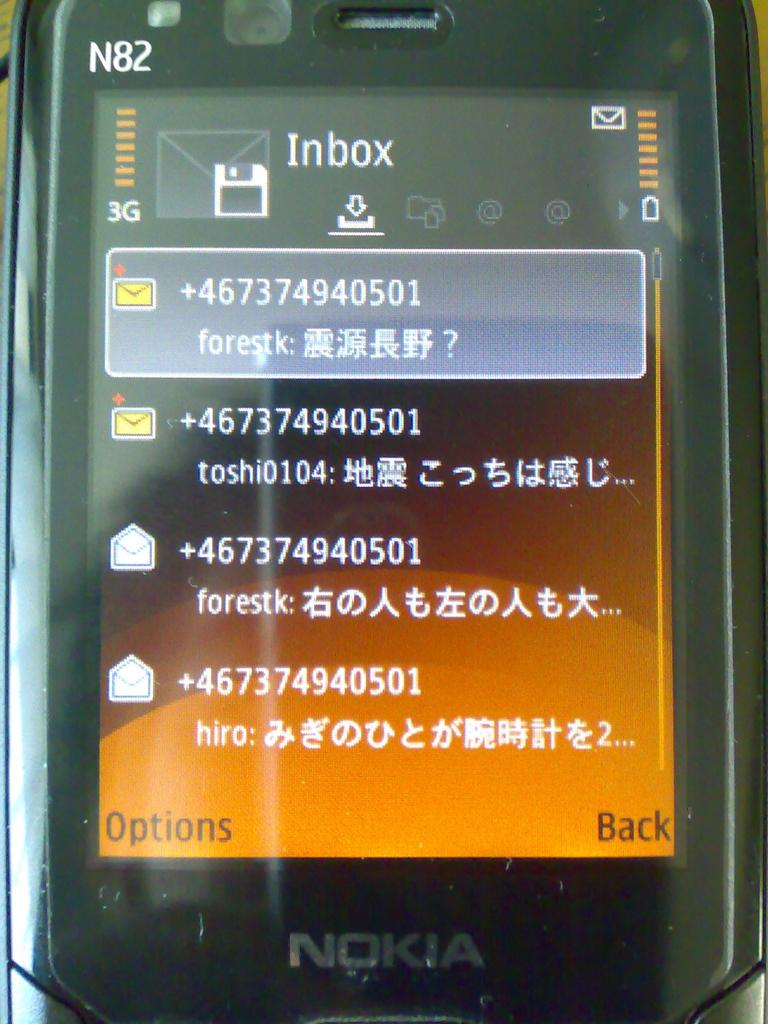<image>
Present a compact description of the photo's key features. A Nokia phone is displaying the user's inbox. 